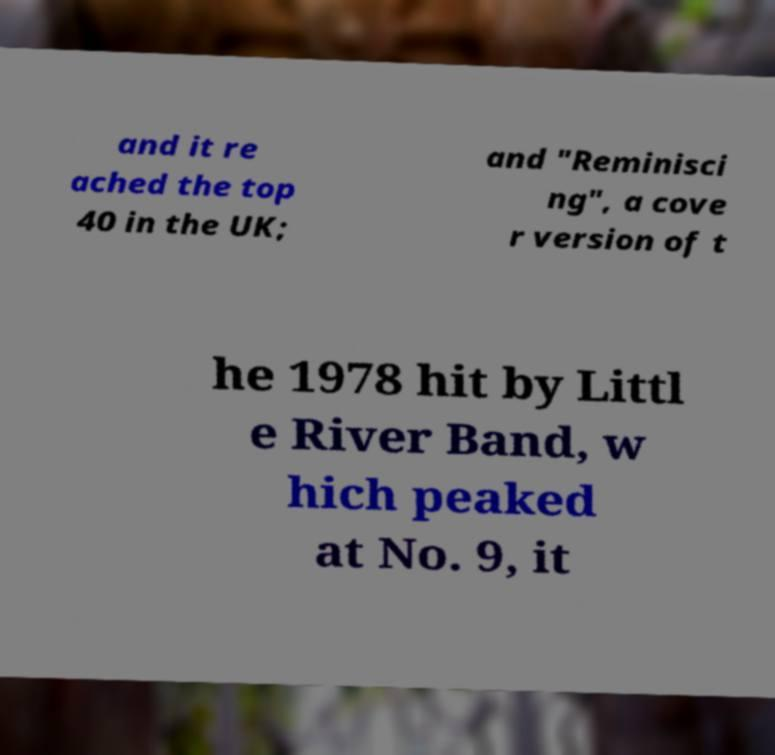For documentation purposes, I need the text within this image transcribed. Could you provide that? and it re ached the top 40 in the UK; and "Reminisci ng", a cove r version of t he 1978 hit by Littl e River Band, w hich peaked at No. 9, it 